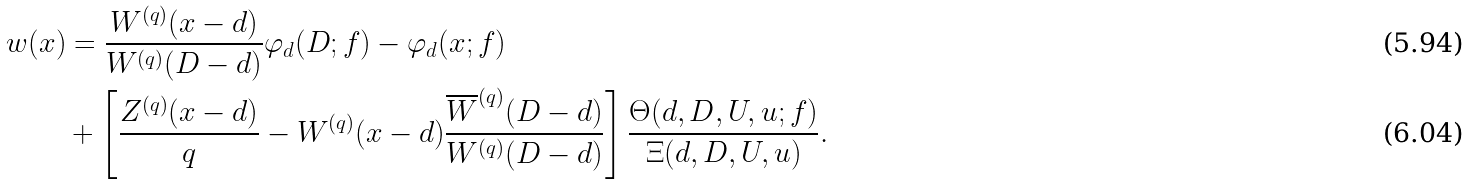<formula> <loc_0><loc_0><loc_500><loc_500>w ( x ) & = \frac { W ^ { ( q ) } ( x - d ) } { W ^ { ( q ) } ( D - d ) } \varphi _ { d } ( D ; f ) - \varphi _ { d } ( x ; f ) \\ & + \left [ \frac { Z ^ { ( q ) } ( x - d ) } q - { W ^ { ( q ) } ( x - d ) } \frac { \overline { W } ^ { ( q ) } ( D - d ) } { W ^ { ( q ) } ( D - d ) } \right ] \frac { \Theta ( d , D , U , u ; f ) } { \Xi ( d , D , U , u ) } .</formula> 